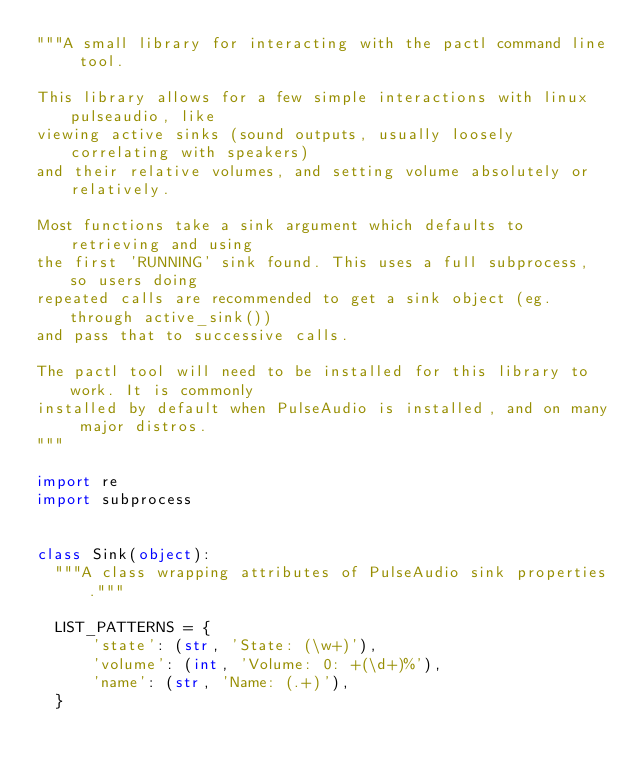Convert code to text. <code><loc_0><loc_0><loc_500><loc_500><_Python_>"""A small library for interacting with the pactl command line tool.

This library allows for a few simple interactions with linux pulseaudio, like
viewing active sinks (sound outputs, usually loosely correlating with speakers)
and their relative volumes, and setting volume absolutely or relatively.

Most functions take a sink argument which defaults to retrieving and using
the first 'RUNNING' sink found. This uses a full subprocess, so users doing
repeated calls are recommended to get a sink object (eg. through active_sink())
and pass that to successive calls.

The pactl tool will need to be installed for this library to work. It is commonly
installed by default when PulseAudio is installed, and on many major distros.
"""

import re
import subprocess


class Sink(object):
  """A class wrapping attributes of PulseAudio sink properties."""

  LIST_PATTERNS = {
      'state': (str, 'State: (\w+)'),
      'volume': (int, 'Volume: 0: +(\d+)%'),
      'name': (str, 'Name: (.+)'),
  }
</code> 